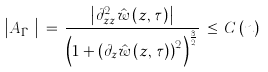<formula> <loc_0><loc_0><loc_500><loc_500>\left | A _ { \bar { \Gamma } _ { \tau } } \right | \, = \, \frac { \left | \partial _ { z z } ^ { 2 } \hat { w } \left ( z , \, \tau \right ) \right | } { \left ( 1 + \left ( \partial _ { z } \hat { w } \left ( z , \, \tau \right ) \right ) ^ { 2 } \right ) ^ { \frac { 3 } { 2 } } } \, \leq \, C \left ( n \right )</formula> 